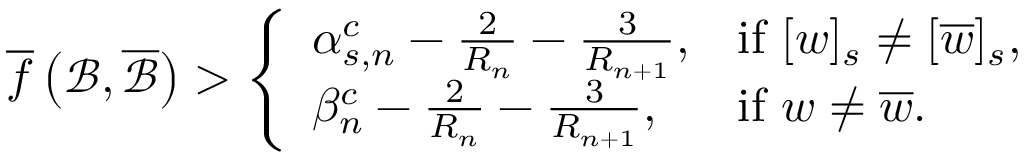<formula> <loc_0><loc_0><loc_500><loc_500>\overline { f } \left ( \mathcal { B } , \overline { { \mathcal { B } } } \right ) > \left \{ \begin{array} { l l } { \alpha _ { s , n } ^ { c } - \frac { 2 } { R _ { n } } - \frac { 3 } { R _ { n + 1 } } , } & { i f [ w ] _ { s } \neq [ \overline { w } ] _ { s } , } \\ { \beta _ { n } ^ { c } - \frac { 2 } { R _ { n } } - \frac { 3 } { R _ { n + 1 } } , } & { i f w \neq \overline { w } . } \end{array}</formula> 